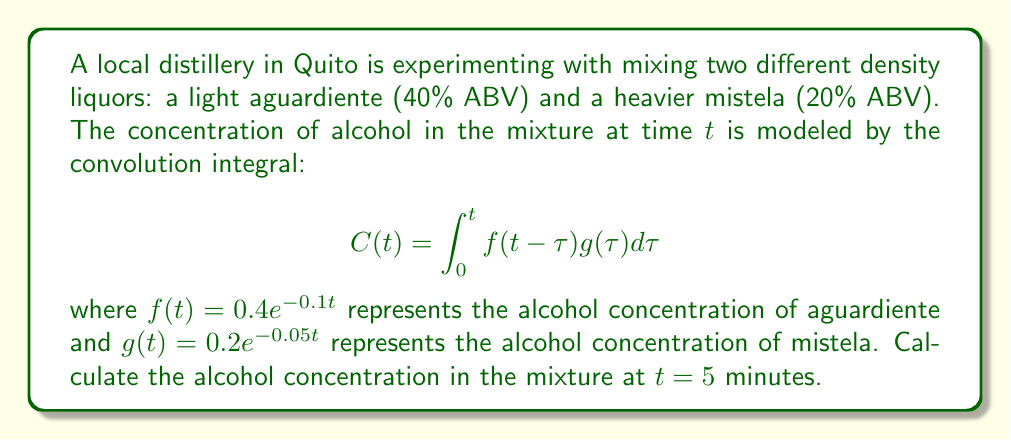What is the answer to this math problem? To solve this problem, we need to evaluate the convolution integral at $t = 5$:

1) First, let's set up the integral:
   $$C(5) = \int_0^5 f(5-\tau)g(\tau)d\tau$$

2) Substitute the given functions:
   $$C(5) = \int_0^5 (0.4e^{-0.1(5-\tau)})(0.2e^{-0.05\tau})d\tau$$

3) Simplify:
   $$C(5) = 0.08e^{-0.5}\int_0^5 e^{0.05\tau}d\tau$$

4) Evaluate the integral:
   $$C(5) = 0.08e^{-0.5}[\frac{1}{0.05}e^{0.05\tau}]_0^5$$

5) Solve:
   $$C(5) = 0.08e^{-0.5}(\frac{1}{0.05}e^{0.25} - \frac{1}{0.05})$$
   $$C(5) = 1.6e^{-0.5}(e^{0.25} - 1)$$

6) Calculate the final value:
   $$C(5) \approx 0.3919$$

Therefore, the alcohol concentration in the mixture at $t = 5$ minutes is approximately 0.3919 or 39.19%.
Answer: $0.3919$ or $39.19\%$ 